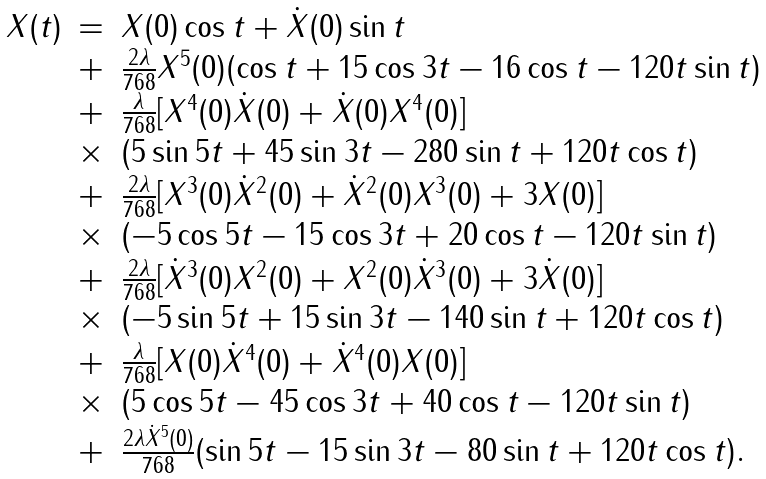Convert formula to latex. <formula><loc_0><loc_0><loc_500><loc_500>\begin{array} { l c l } X ( t ) & = & X ( 0 ) \cos t + \dot { X } ( 0 ) \sin t \\ & + & \frac { 2 \lambda } { 7 6 8 } X ^ { 5 } ( 0 ) ( \cos t + 1 5 \cos 3 t - 1 6 \cos t - 1 2 0 t \sin t ) \\ & + & \frac { \lambda } { 7 6 8 } [ X ^ { 4 } ( 0 ) \dot { X } ( 0 ) + \dot { X } ( 0 ) X ^ { 4 } ( 0 ) ] \\ & \times & ( 5 \sin 5 t + 4 5 \sin 3 t - 2 8 0 \sin t + 1 2 0 t \cos t ) \\ & + & \frac { 2 \lambda } { 7 6 8 } [ X ^ { 3 } ( 0 ) \dot { X } ^ { 2 } ( 0 ) + \dot { X } ^ { 2 } ( 0 ) X ^ { 3 } ( 0 ) + 3 X ( 0 ) ] \\ & \times & ( - 5 \cos 5 t - 1 5 \cos 3 t + 2 0 \cos t - 1 2 0 t \sin t ) \\ & + & \frac { 2 \lambda } { 7 6 8 } [ \dot { X } ^ { 3 } ( 0 ) X ^ { 2 } ( 0 ) + X ^ { 2 } ( 0 ) \dot { X } ^ { 3 } ( 0 ) + 3 \dot { X } ( 0 ) ] \\ & \times & ( - 5 \sin 5 t + 1 5 \sin 3 t - 1 4 0 \sin t + 1 2 0 t \cos t ) \\ & + & \frac { \lambda } { 7 6 8 } [ X ( 0 ) \dot { X } ^ { 4 } ( 0 ) + \dot { X } ^ { 4 } ( 0 ) X ( 0 ) ] \\ & \times & ( 5 \cos 5 t - 4 5 \cos 3 t + 4 0 \cos t - 1 2 0 t \sin t ) \\ & + & \frac { 2 \lambda \dot { X } ^ { 5 } ( 0 ) } { 7 6 8 } ( \sin 5 t - 1 5 \sin 3 t - 8 0 \sin t + 1 2 0 t \cos t ) . \\ & & \end{array}</formula> 